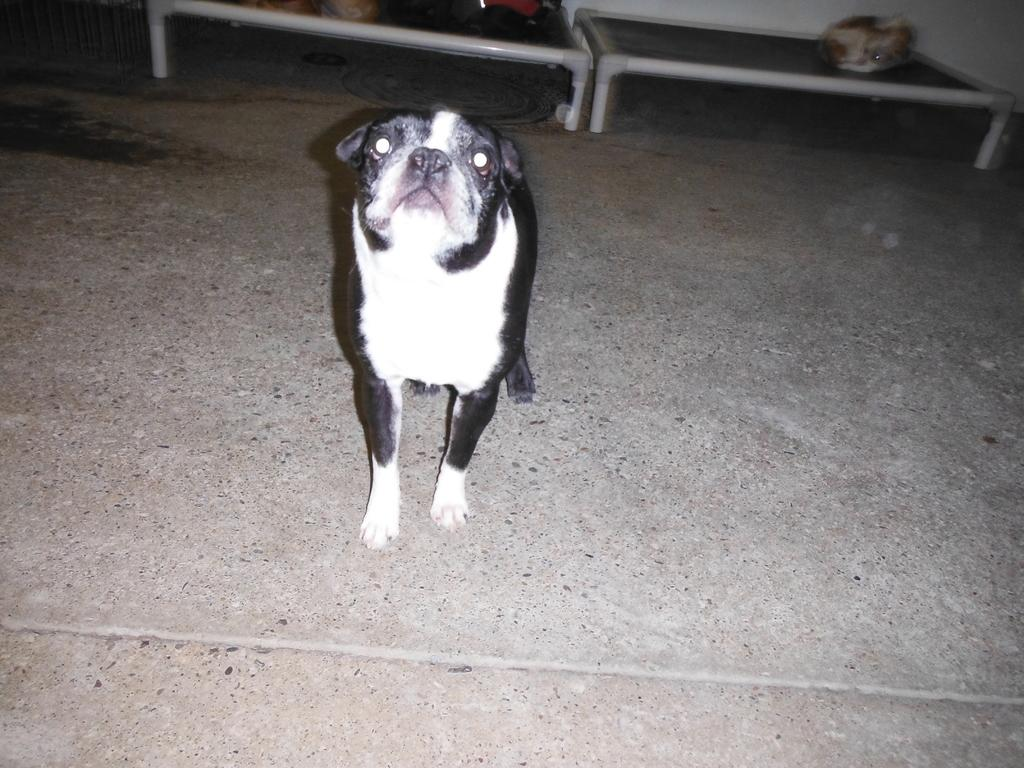What type of animal is in the image? There is a dog in the image. Where is the dog located in the image? The dog is on the floor. What can be seen in the background of the image? There are objects in the background of the image. What type of knee injury does the dog have in the image? There is no indication of a knee injury in the image; the dog is simply on the floor. 